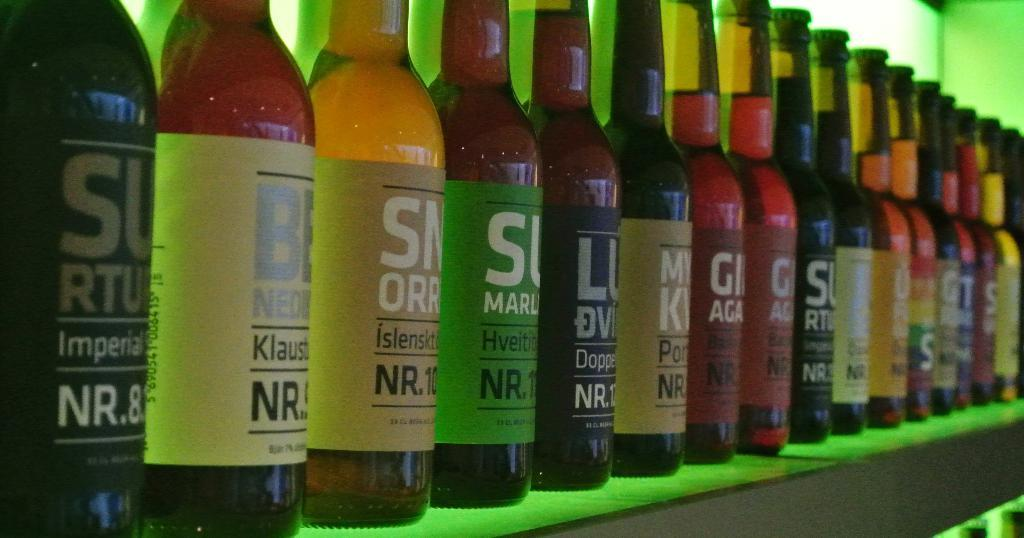<image>
Render a clear and concise summary of the photo. The closest bottle in the display says Imperial NR.8. 